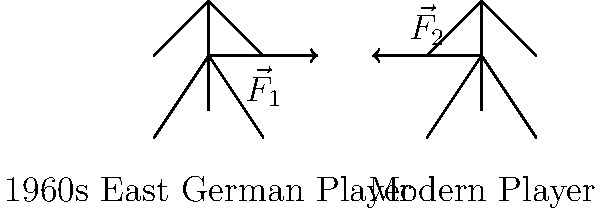Compare the force vectors $\vec{F}_1$ and $\vec{F}_2$ in the sliding tackle illustration above, representing a 1960s East German player and a modern player respectively. Which vector is likely to have a greater magnitude and why? To answer this question, we need to consider several factors:

1. Physical conditioning: Modern players generally have better physical conditioning due to advancements in training methods and nutrition.

2. Playing surface: East German players in the 1960s often played on harder, less maintained surfaces, which could affect tackling technique.

3. Rule changes: Modern football has stricter rules regarding tackling, potentially influencing the force applied.

4. Equipment: Modern players wear lighter, more flexible boots, allowing for more controlled tackles.

5. Tactical evolution: The modern game emphasizes possession, leading to more precise, controlled tackles.

6. Political influence: East German football in the 1960s was influenced by the state's desire for physical prowess, potentially encouraging more forceful play.

Considering these factors:

- The modern player ($\vec{F}_2$) is likely to apply a more controlled, precise force due to better training, equipment, and rule constraints.
- The 1960s East German player ($\vec{F}_1$) might apply a greater force due to less restrictive rules, harder playing surfaces, and the political emphasis on physical dominance.

Therefore, $\vec{F}_1$ is likely to have a greater magnitude than $\vec{F}_2$.
Answer: $\vec{F}_1$ (1960s East German player) 